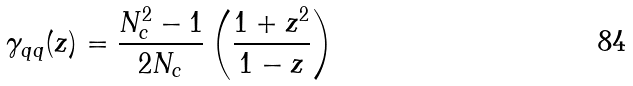Convert formula to latex. <formula><loc_0><loc_0><loc_500><loc_500>\gamma _ { q q } ( z ) = \frac { N ^ { 2 } _ { c } - 1 } { 2 N _ { c } } \left ( \frac { 1 + z ^ { 2 } } { 1 - z } \right )</formula> 